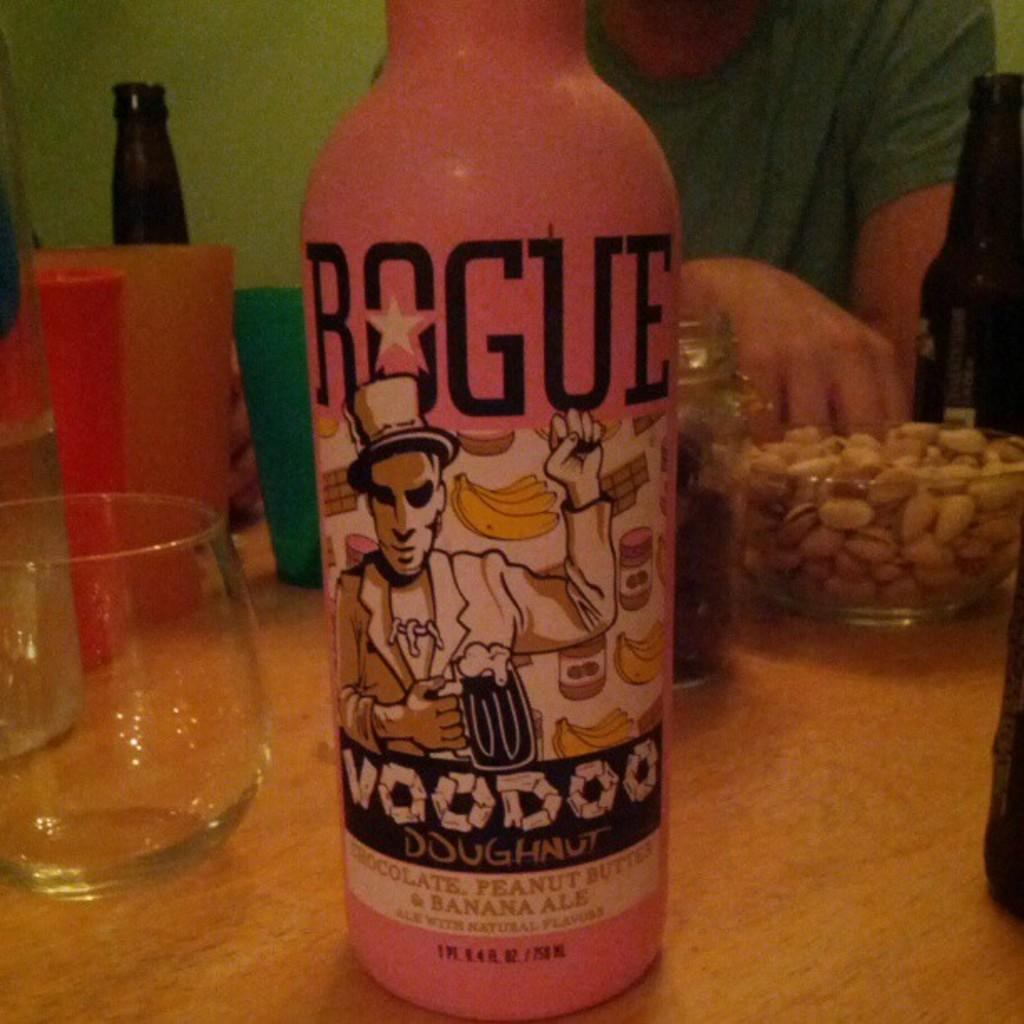<image>
Relay a brief, clear account of the picture shown. A hand reaches into a bowl of peanuts sitting on a table that also has a pink bottle of chcolate, peanut butter and banana ale on it. 